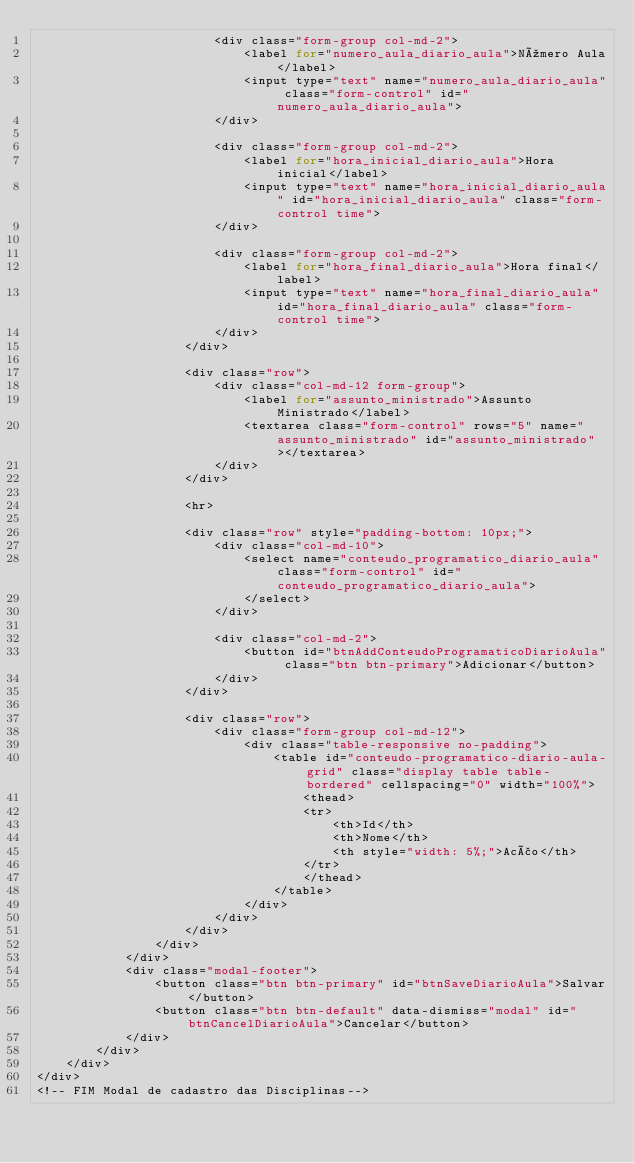<code> <loc_0><loc_0><loc_500><loc_500><_PHP_>                        <div class="form-group col-md-2">
                            <label for="numero_aula_diario_aula">Número Aula</label>
                            <input type="text" name="numero_aula_diario_aula" class="form-control" id="numero_aula_diario_aula">
                        </div>

                        <div class="form-group col-md-2">
                            <label for="hora_inicial_diario_aula">Hora inicial</label>
                            <input type="text" name="hora_inicial_diario_aula" id="hora_inicial_diario_aula" class="form-control time">
                        </div>

                        <div class="form-group col-md-2">
                            <label for="hora_final_diario_aula">Hora final</label>
                            <input type="text" name="hora_final_diario_aula" id="hora_final_diario_aula" class="form-control time">
                        </div>
                    </div>

                    <div class="row">
                        <div class="col-md-12 form-group">
                            <label for="assunto_ministrado">Assunto Ministrado</label>
                            <textarea class="form-control" rows="5" name="assunto_ministrado" id="assunto_ministrado"></textarea>
                        </div>
                    </div>

                    <hr>

                    <div class="row" style="padding-bottom: 10px;">
                        <div class="col-md-10">
                            <select name="conteudo_programatico_diario_aula" class="form-control" id="conteudo_programatico_diario_aula">
                            </select>
                        </div>

                        <div class="col-md-2">
                            <button id="btnAddConteudoProgramaticoDiarioAula" class="btn btn-primary">Adicionar</button>
                        </div>
                    </div>

                    <div class="row">
                        <div class="form-group col-md-12">
                            <div class="table-responsive no-padding">
                                <table id="conteudo-programatico-diario-aula-grid" class="display table table-bordered" cellspacing="0" width="100%">
                                    <thead>
                                    <tr>
                                        <th>Id</th>
                                        <th>Nome</th>
                                        <th style="width: 5%;">Acão</th>
                                    </tr>
                                    </thead>
                                </table>
                            </div>
                        </div>
                    </div>
                </div>
            </div>
            <div class="modal-footer">
                <button class="btn btn-primary" id="btnSaveDiarioAula">Salvar</button>
                <button class="btn btn-default" data-dismiss="modal" id="btnCancelDiarioAula">Cancelar</button>
            </div>
        </div>
    </div>
</div>
<!-- FIM Modal de cadastro das Disciplinas--></code> 